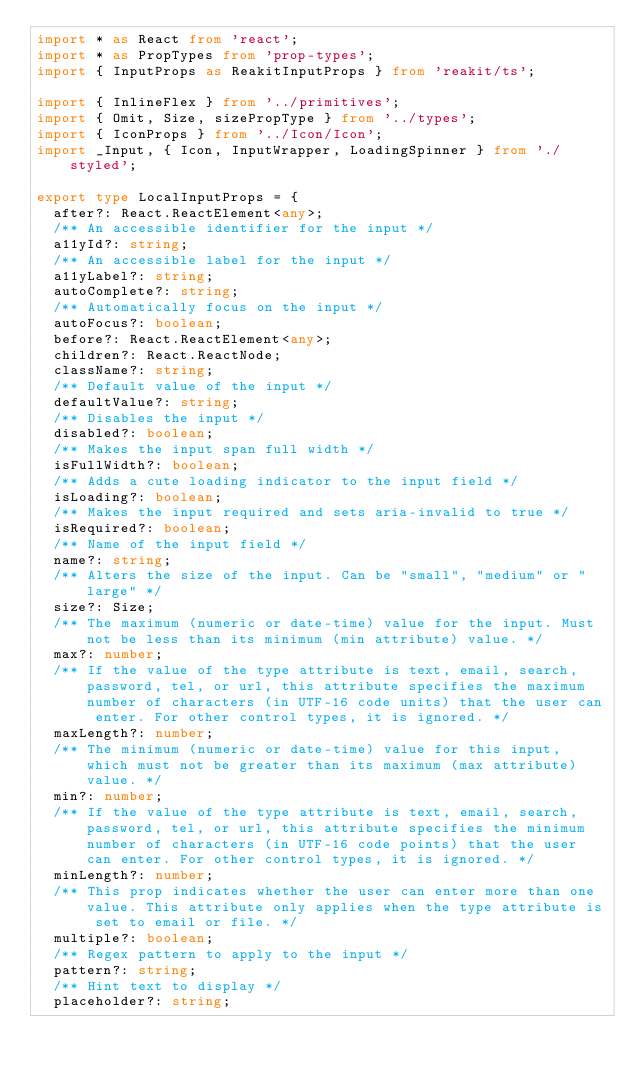Convert code to text. <code><loc_0><loc_0><loc_500><loc_500><_TypeScript_>import * as React from 'react';
import * as PropTypes from 'prop-types';
import { InputProps as ReakitInputProps } from 'reakit/ts';

import { InlineFlex } from '../primitives';
import { Omit, Size, sizePropType } from '../types';
import { IconProps } from '../Icon/Icon';
import _Input, { Icon, InputWrapper, LoadingSpinner } from './styled';

export type LocalInputProps = {
  after?: React.ReactElement<any>;
  /** An accessible identifier for the input */
  a11yId?: string;
  /** An accessible label for the input */
  a11yLabel?: string;
  autoComplete?: string;
  /** Automatically focus on the input */
  autoFocus?: boolean;
  before?: React.ReactElement<any>;
  children?: React.ReactNode;
  className?: string;
  /** Default value of the input */
  defaultValue?: string;
  /** Disables the input */
  disabled?: boolean;
  /** Makes the input span full width */
  isFullWidth?: boolean;
  /** Adds a cute loading indicator to the input field */
  isLoading?: boolean;
  /** Makes the input required and sets aria-invalid to true */
  isRequired?: boolean;
  /** Name of the input field */
  name?: string;
  /** Alters the size of the input. Can be "small", "medium" or "large" */
  size?: Size;
  /** The maximum (numeric or date-time) value for the input. Must not be less than its minimum (min attribute) value. */
  max?: number;
  /** If the value of the type attribute is text, email, search, password, tel, or url, this attribute specifies the maximum number of characters (in UTF-16 code units) that the user can enter. For other control types, it is ignored. */
  maxLength?: number;
  /** The minimum (numeric or date-time) value for this input, which must not be greater than its maximum (max attribute) value. */
  min?: number;
  /** If the value of the type attribute is text, email, search, password, tel, or url, this attribute specifies the minimum number of characters (in UTF-16 code points) that the user can enter. For other control types, it is ignored. */
  minLength?: number;
  /** This prop indicates whether the user can enter more than one value. This attribute only applies when the type attribute is set to email or file. */
  multiple?: boolean;
  /** Regex pattern to apply to the input */
  pattern?: string;
  /** Hint text to display */
  placeholder?: string;</code> 